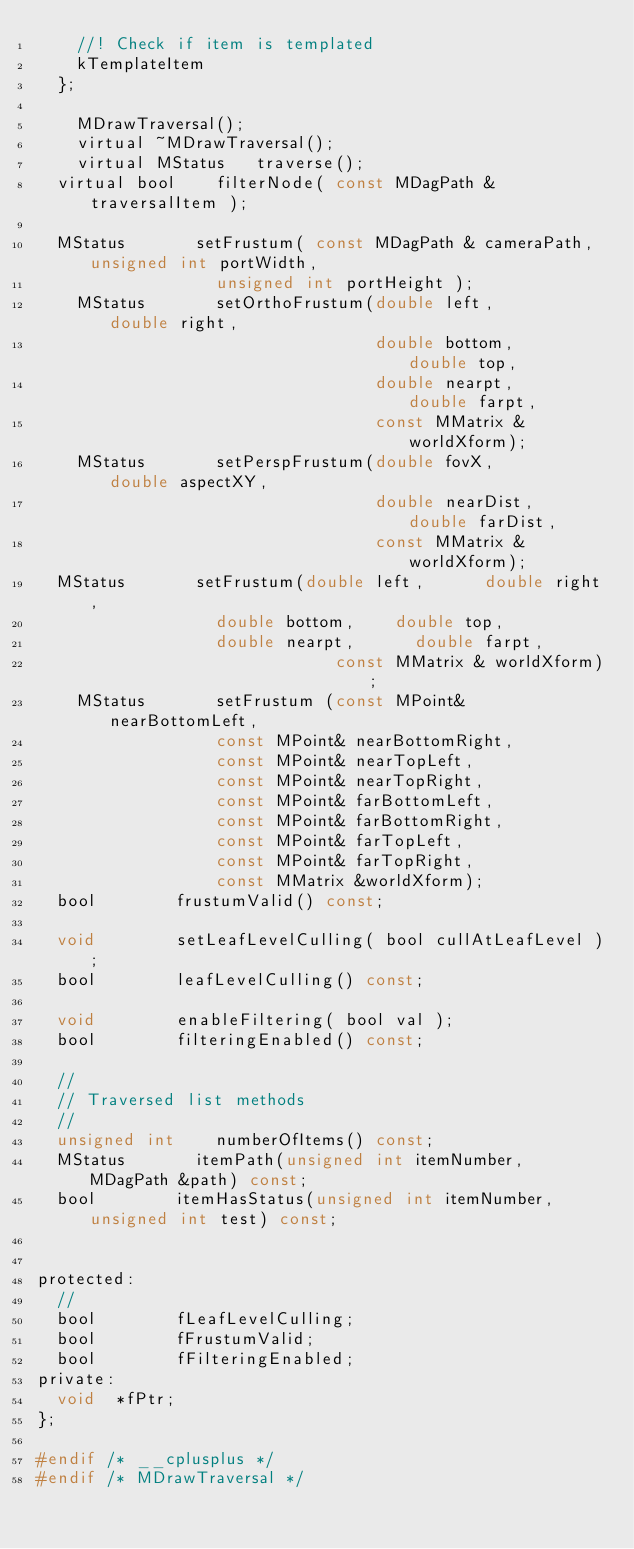<code> <loc_0><loc_0><loc_500><loc_500><_C_>		//! Check if item is templated
		kTemplateItem
	};

    MDrawTraversal();
    virtual ~MDrawTraversal();
    virtual MStatus		traverse();
	virtual bool		filterNode( const MDagPath &traversalItem );

	MStatus				setFrustum( const MDagPath & cameraPath, unsigned int portWidth,
									unsigned int portHeight );
    MStatus				setOrthoFrustum(double left,      double right,
                             			double bottom,    double top,
                             			double nearpt,      double farpt,
                             			const MMatrix & worldXform);
    MStatus				setPerspFrustum(double fovX,      double aspectXY,
                            			double nearDist,  double farDist,
                             			const MMatrix & worldXform);
	MStatus				setFrustum(double left,      double right,
									double bottom,    double top,
									double nearpt,      double farpt,
                             	const MMatrix & worldXform);
    MStatus				setFrustum (const MPoint& nearBottomLeft,
									const MPoint& nearBottomRight,
									const MPoint& nearTopLeft,
									const MPoint& nearTopRight,
									const MPoint& farBottomLeft,
									const MPoint& farBottomRight,
									const MPoint& farTopLeft,
									const MPoint& farTopRight,
									const MMatrix &worldXform);
	bool				frustumValid() const;

	void				setLeafLevelCulling( bool cullAtLeafLevel );
	bool				leafLevelCulling() const;

	void				enableFiltering( bool val );
	bool				filteringEnabled() const;

	//
	// Traversed list methods
	//
	unsigned int		numberOfItems() const;
	MStatus				itemPath(unsigned int itemNumber, MDagPath &path) const;
	bool				itemHasStatus(unsigned int itemNumber, unsigned int test) const;


protected:
	//
	bool				fLeafLevelCulling;
	bool				fFrustumValid;
	bool				fFilteringEnabled;
private:
	void	*fPtr;
};

#endif /* __cplusplus */
#endif /* MDrawTraversal */
</code> 